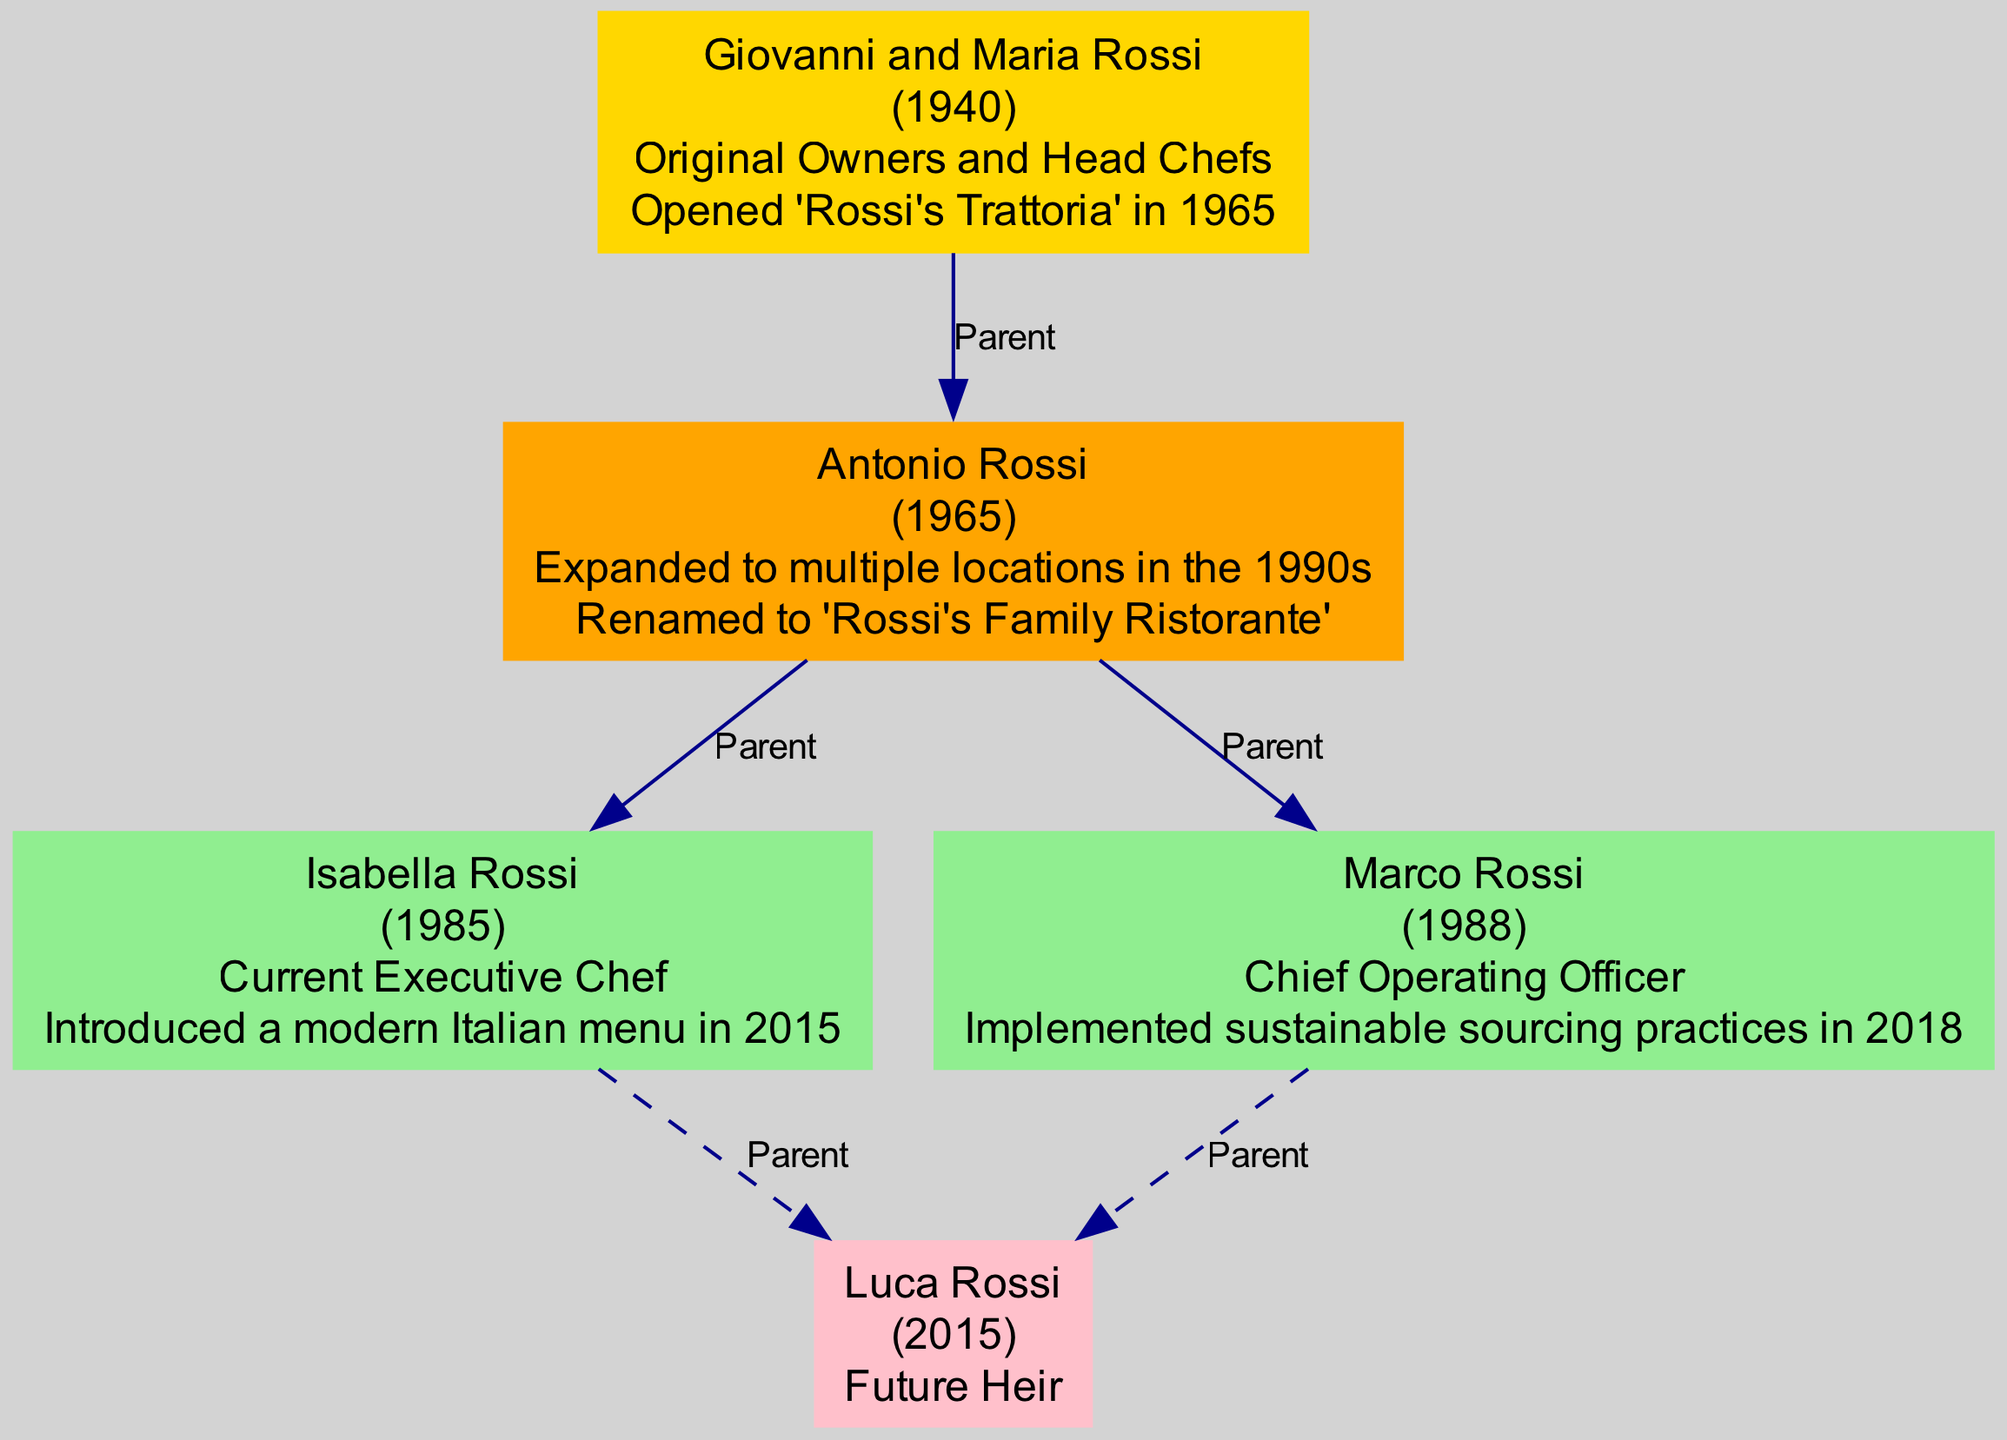What year did Giovanni and Maria Rossi open their restaurant? According to the diagram, Giovanni and Maria Rossi opened 'Rossi's Trattoria' in 1965. This key event is stated directly under their node as a significant milestone.
Answer: 1965 Who is the current executive chef? The diagram indicates that Isabella Rossi, born in 1985, is the current executive chef. Her role is clearly defined in the third generation section of the diagram.
Answer: Isabella Rossi How many third-generation members are listed? The diagram shows two third-generation members: Isabella Rossi and Marco Rossi. They are represented as separate nodes under the third generation.
Answer: 2 What was the key event for Antonio Rossi? The diagram states that Antonio Rossi renamed the restaurant to 'Rossi's Family Ristorante.' This information is displayed under his node, which summarizes his contributions.
Answer: Renamed to 'Rossi's Family Ristorante' Which generation is Luca Rossi part of? The diagram indicates that Luca Rossi belongs to the future generation, as he is explicitly labeled as such in his node, distinguishing him from the current generations.
Answer: Future Generation What sustainable practice did Marco Rossi implement? According to the diagram, Marco Rossi implemented sustainable sourcing practices in 2018. This is identified as his key event under the third-generation node.
Answer: Sustainable sourcing practices Who are the founders of the restaurant? Giovanni and Maria Rossi are named in the founders' node, marked as the original owners and head chefs. This information is clearly provided in the family tree.
Answer: Giovanni and Maria Rossi Which generation did the expansion to multiple locations occur? The expansion to multiple locations is associated with the second generation, specifically attributed to Antonio Rossi in the 1990s as noted in his key event.
Answer: Second Generation What role does Luca Rossi hold? Luca Rossi is identified as the future heir in the diagram. This role is mentioned under his node in the future generation section.
Answer: Future Heir 